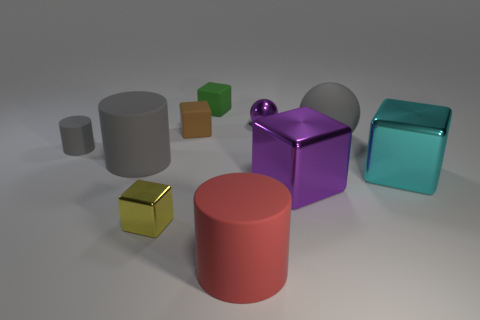There is a small shiny object in front of the large gray cylinder; does it have the same color as the small matte cylinder?
Offer a very short reply. No. Are there any tiny gray things right of the brown matte block?
Offer a very short reply. No. There is a large matte thing that is on the right side of the yellow metallic object and behind the big cyan block; what color is it?
Ensure brevity in your answer.  Gray. What shape is the large metallic thing that is the same color as the small sphere?
Your answer should be compact. Cube. There is a purple metal object in front of the cyan shiny object in front of the big sphere; what is its size?
Offer a terse response. Large. What number of blocks are tiny blue matte things or tiny matte objects?
Provide a succinct answer. 2. The metal block that is the same size as the green thing is what color?
Make the answer very short. Yellow. There is a small metal thing to the right of the tiny metallic object that is in front of the purple ball; what is its shape?
Ensure brevity in your answer.  Sphere. Is the size of the ball behind the gray ball the same as the cyan block?
Offer a terse response. No. What number of other things are made of the same material as the yellow thing?
Your answer should be compact. 3. 